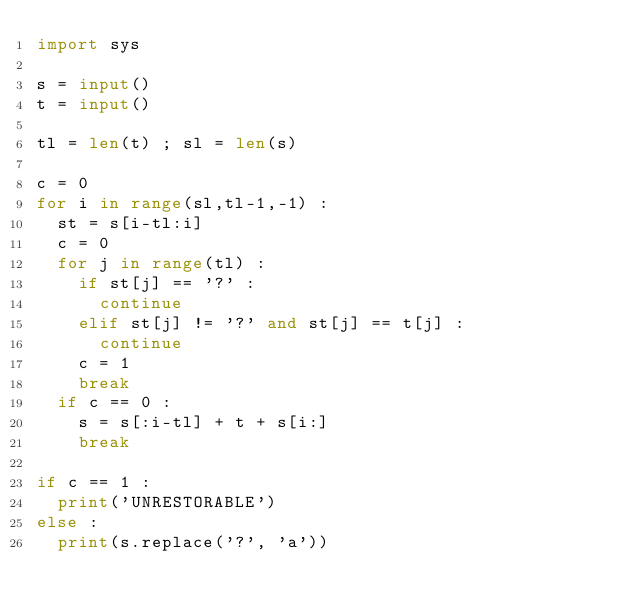Convert code to text. <code><loc_0><loc_0><loc_500><loc_500><_Python_>import sys

s = input()
t = input()

tl = len(t) ; sl = len(s)

c = 0
for i in range(sl,tl-1,-1) :
  st = s[i-tl:i]
  c = 0
  for j in range(tl) :
    if st[j] == '?' :
      continue
    elif st[j] != '?' and st[j] == t[j] :
      continue
    c = 1
    break
  if c == 0 :
    s = s[:i-tl] + t + s[i:]
    break

if c == 1 :
  print('UNRESTORABLE')
else : 
  print(s.replace('?', 'a'))</code> 